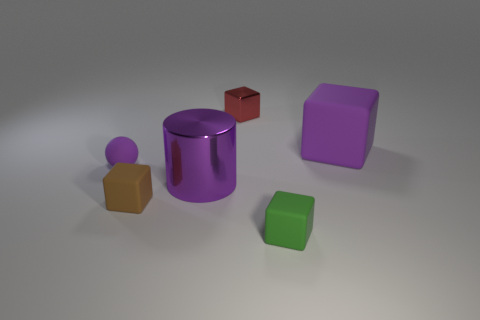Add 1 green blocks. How many objects exist? 7 Subtract all spheres. How many objects are left? 5 Subtract 0 brown cylinders. How many objects are left? 6 Subtract all green matte cylinders. Subtract all small red shiny objects. How many objects are left? 5 Add 2 tiny things. How many tiny things are left? 6 Add 1 gray shiny cylinders. How many gray shiny cylinders exist? 1 